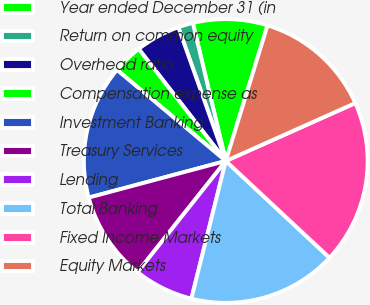Convert chart to OTSL. <chart><loc_0><loc_0><loc_500><loc_500><pie_chart><fcel>Year ended December 31 (in<fcel>Return on common equity<fcel>Overhead ratio<fcel>Compensation expense as<fcel>Investment Banking<fcel>Treasury Services<fcel>Lending<fcel>Total Banking<fcel>Fixed Income Markets<fcel>Equity Markets<nl><fcel>8.48%<fcel>1.7%<fcel>5.09%<fcel>3.39%<fcel>15.25%<fcel>10.17%<fcel>6.78%<fcel>16.95%<fcel>18.64%<fcel>13.56%<nl></chart> 